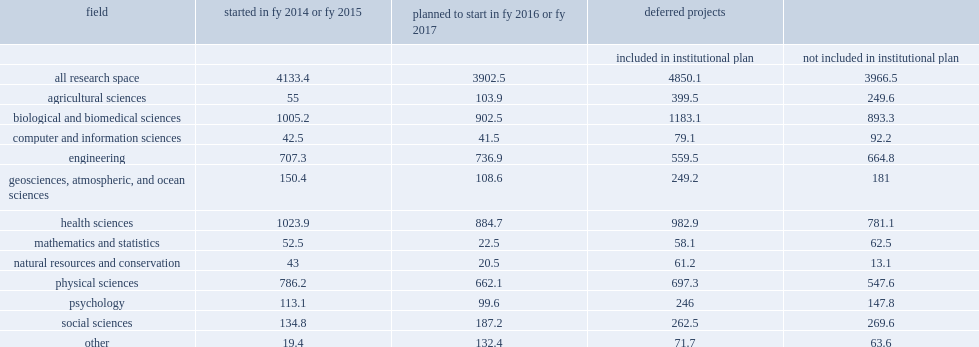How many million dollars did academic institutions expend on major repairs and renovation of s&e research space in fys 2014-15? 4133.4. How many percent did improvements to research space in health sciences comprise of those costs? 0.247714. How many percent were substantial shares of overall costs for research space repair and renovation were accounted for by biological and biomedical sciences? 0.24319. How many percent were substantial shares of overall costs for research space repair and renovation accounted for by physical sciences? 0.190207. How many percent were substantial shares of overall costs for research space repair and renovation accounted for by engineering? 0.171118. 